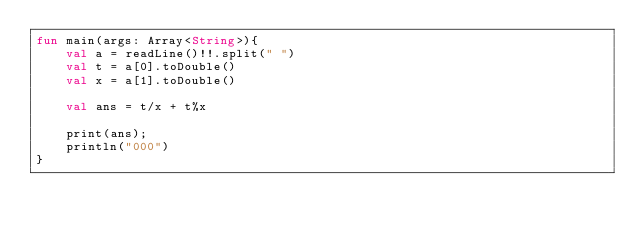Convert code to text. <code><loc_0><loc_0><loc_500><loc_500><_Kotlin_>fun main(args: Array<String>){
    val a = readLine()!!.split(" ")
    val t = a[0].toDouble()
    val x = a[1].toDouble()

    val ans = t/x + t%x

    print(ans);
    println("000")
}
</code> 